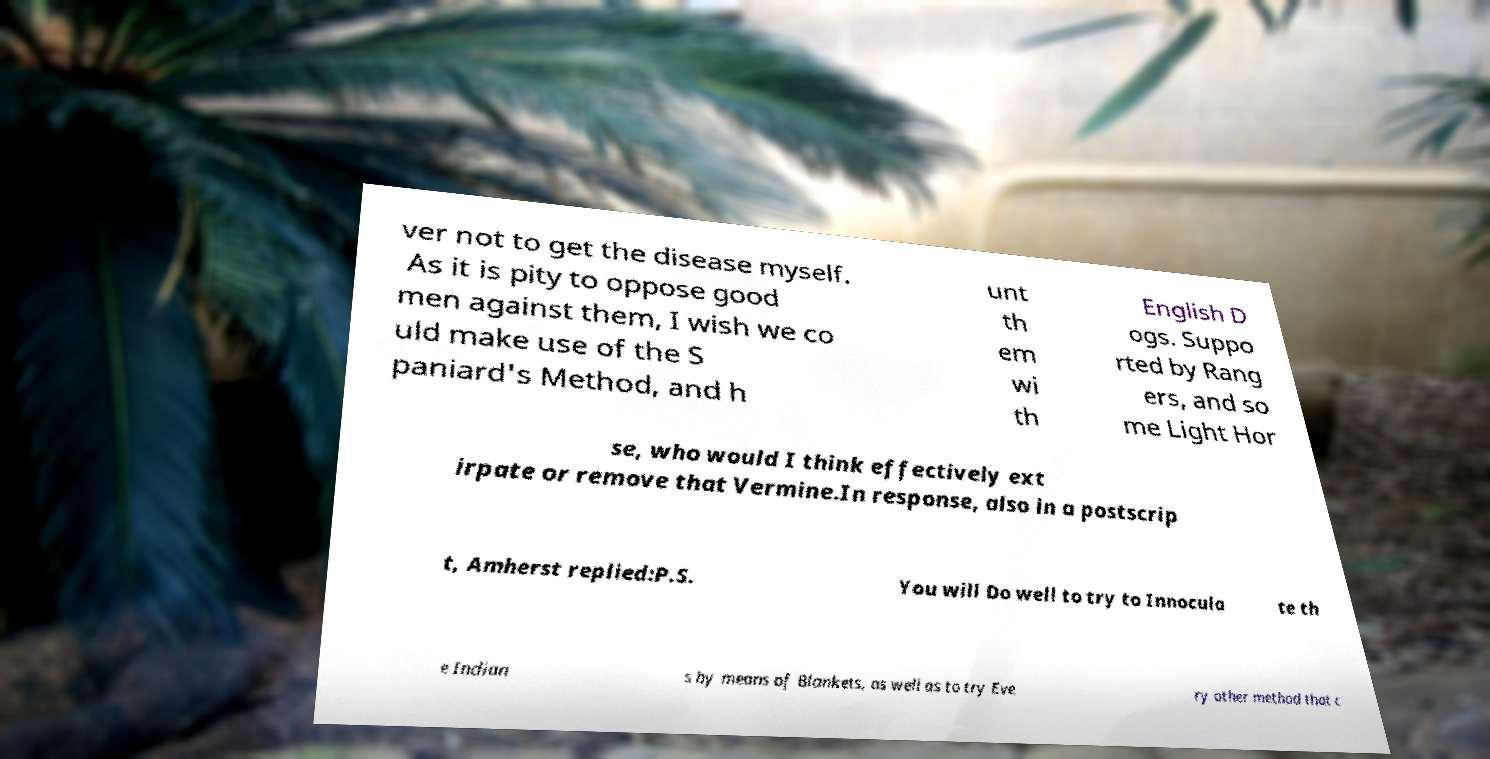Could you extract and type out the text from this image? ver not to get the disease myself. As it is pity to oppose good men against them, I wish we co uld make use of the S paniard's Method, and h unt th em wi th English D ogs. Suppo rted by Rang ers, and so me Light Hor se, who would I think effectively ext irpate or remove that Vermine.In response, also in a postscrip t, Amherst replied:P.S. You will Do well to try to Innocula te th e Indian s by means of Blankets, as well as to try Eve ry other method that c 